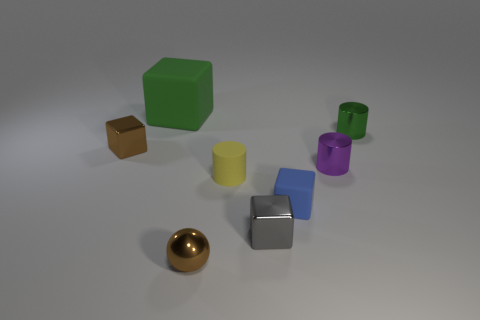Add 1 purple objects. How many objects exist? 9 Subtract all cylinders. How many objects are left? 5 Subtract all big purple cylinders. Subtract all green objects. How many objects are left? 6 Add 1 brown blocks. How many brown blocks are left? 2 Add 7 tiny gray rubber spheres. How many tiny gray rubber spheres exist? 7 Subtract 1 yellow cylinders. How many objects are left? 7 